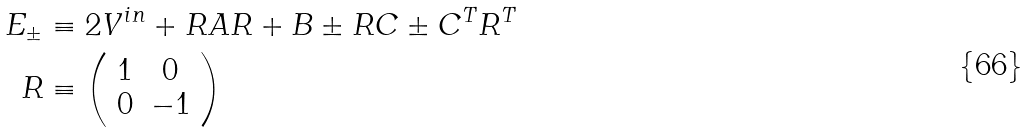<formula> <loc_0><loc_0><loc_500><loc_500>E _ { \pm } & \equiv 2 V ^ { i n } + R A R + B \pm R C \pm C ^ { T } R ^ { T } \\ R & \equiv \left ( \begin{array} [ c ] { c c } 1 & 0 \\ 0 & - 1 \end{array} \right )</formula> 